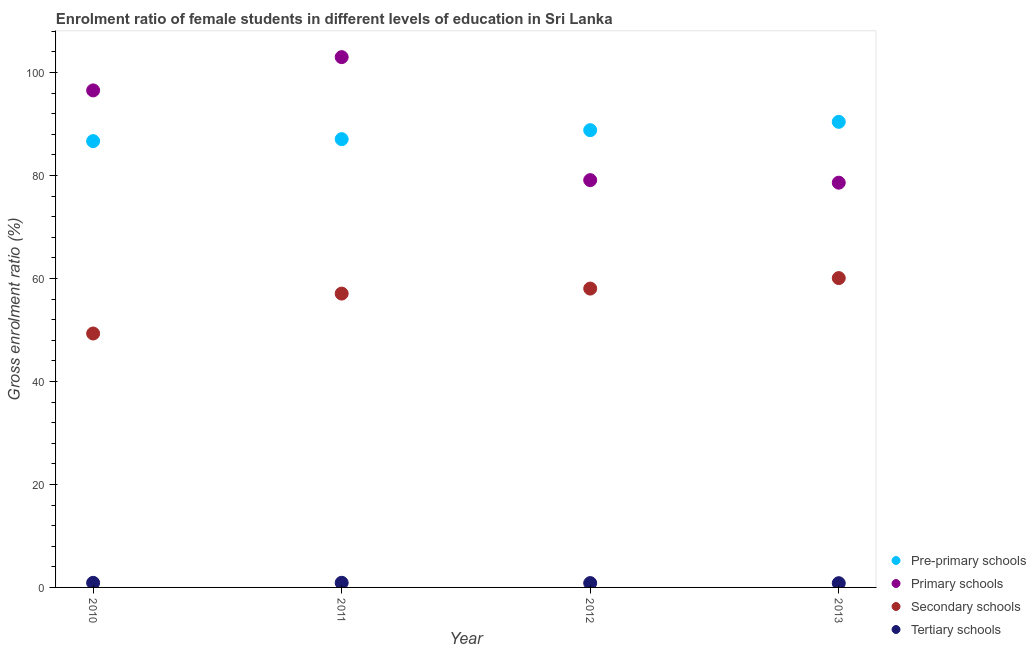How many different coloured dotlines are there?
Offer a terse response. 4. Is the number of dotlines equal to the number of legend labels?
Keep it short and to the point. Yes. What is the gross enrolment ratio(male) in secondary schools in 2013?
Provide a succinct answer. 60.08. Across all years, what is the maximum gross enrolment ratio(male) in pre-primary schools?
Offer a very short reply. 90.43. Across all years, what is the minimum gross enrolment ratio(male) in pre-primary schools?
Provide a short and direct response. 86.68. In which year was the gross enrolment ratio(male) in tertiary schools maximum?
Offer a very short reply. 2011. In which year was the gross enrolment ratio(male) in secondary schools minimum?
Your answer should be compact. 2010. What is the total gross enrolment ratio(male) in pre-primary schools in the graph?
Your answer should be very brief. 352.99. What is the difference between the gross enrolment ratio(male) in secondary schools in 2012 and that in 2013?
Offer a very short reply. -2.04. What is the difference between the gross enrolment ratio(male) in secondary schools in 2012 and the gross enrolment ratio(male) in tertiary schools in 2013?
Provide a short and direct response. 57.22. What is the average gross enrolment ratio(male) in primary schools per year?
Give a very brief answer. 89.31. In the year 2012, what is the difference between the gross enrolment ratio(male) in primary schools and gross enrolment ratio(male) in tertiary schools?
Offer a terse response. 78.27. What is the ratio of the gross enrolment ratio(male) in tertiary schools in 2010 to that in 2012?
Keep it short and to the point. 1.06. What is the difference between the highest and the second highest gross enrolment ratio(male) in pre-primary schools?
Offer a terse response. 1.62. What is the difference between the highest and the lowest gross enrolment ratio(male) in secondary schools?
Give a very brief answer. 10.76. In how many years, is the gross enrolment ratio(male) in pre-primary schools greater than the average gross enrolment ratio(male) in pre-primary schools taken over all years?
Offer a very short reply. 2. Is it the case that in every year, the sum of the gross enrolment ratio(male) in secondary schools and gross enrolment ratio(male) in primary schools is greater than the sum of gross enrolment ratio(male) in tertiary schools and gross enrolment ratio(male) in pre-primary schools?
Give a very brief answer. Yes. Is it the case that in every year, the sum of the gross enrolment ratio(male) in pre-primary schools and gross enrolment ratio(male) in primary schools is greater than the gross enrolment ratio(male) in secondary schools?
Keep it short and to the point. Yes. Does the gross enrolment ratio(male) in primary schools monotonically increase over the years?
Your answer should be compact. No. Is the gross enrolment ratio(male) in primary schools strictly greater than the gross enrolment ratio(male) in secondary schools over the years?
Your response must be concise. Yes. Is the gross enrolment ratio(male) in pre-primary schools strictly less than the gross enrolment ratio(male) in tertiary schools over the years?
Ensure brevity in your answer.  No. Where does the legend appear in the graph?
Provide a short and direct response. Bottom right. What is the title of the graph?
Your answer should be compact. Enrolment ratio of female students in different levels of education in Sri Lanka. Does "Oil" appear as one of the legend labels in the graph?
Make the answer very short. No. What is the label or title of the X-axis?
Your answer should be compact. Year. What is the Gross enrolment ratio (%) in Pre-primary schools in 2010?
Offer a terse response. 86.68. What is the Gross enrolment ratio (%) in Primary schools in 2010?
Give a very brief answer. 96.53. What is the Gross enrolment ratio (%) in Secondary schools in 2010?
Keep it short and to the point. 49.32. What is the Gross enrolment ratio (%) of Tertiary schools in 2010?
Give a very brief answer. 0.89. What is the Gross enrolment ratio (%) of Pre-primary schools in 2011?
Keep it short and to the point. 87.07. What is the Gross enrolment ratio (%) of Primary schools in 2011?
Your response must be concise. 103. What is the Gross enrolment ratio (%) of Secondary schools in 2011?
Provide a succinct answer. 57.07. What is the Gross enrolment ratio (%) of Tertiary schools in 2011?
Provide a succinct answer. 0.9. What is the Gross enrolment ratio (%) in Pre-primary schools in 2012?
Your answer should be compact. 88.81. What is the Gross enrolment ratio (%) of Primary schools in 2012?
Keep it short and to the point. 79.11. What is the Gross enrolment ratio (%) in Secondary schools in 2012?
Make the answer very short. 58.04. What is the Gross enrolment ratio (%) of Tertiary schools in 2012?
Offer a very short reply. 0.84. What is the Gross enrolment ratio (%) of Pre-primary schools in 2013?
Offer a very short reply. 90.43. What is the Gross enrolment ratio (%) in Primary schools in 2013?
Your answer should be very brief. 78.61. What is the Gross enrolment ratio (%) of Secondary schools in 2013?
Give a very brief answer. 60.08. What is the Gross enrolment ratio (%) in Tertiary schools in 2013?
Offer a terse response. 0.82. Across all years, what is the maximum Gross enrolment ratio (%) of Pre-primary schools?
Your response must be concise. 90.43. Across all years, what is the maximum Gross enrolment ratio (%) of Primary schools?
Make the answer very short. 103. Across all years, what is the maximum Gross enrolment ratio (%) in Secondary schools?
Offer a terse response. 60.08. Across all years, what is the maximum Gross enrolment ratio (%) of Tertiary schools?
Provide a short and direct response. 0.9. Across all years, what is the minimum Gross enrolment ratio (%) in Pre-primary schools?
Provide a short and direct response. 86.68. Across all years, what is the minimum Gross enrolment ratio (%) in Primary schools?
Provide a succinct answer. 78.61. Across all years, what is the minimum Gross enrolment ratio (%) of Secondary schools?
Your response must be concise. 49.32. Across all years, what is the minimum Gross enrolment ratio (%) in Tertiary schools?
Ensure brevity in your answer.  0.82. What is the total Gross enrolment ratio (%) in Pre-primary schools in the graph?
Offer a very short reply. 352.99. What is the total Gross enrolment ratio (%) of Primary schools in the graph?
Keep it short and to the point. 357.25. What is the total Gross enrolment ratio (%) in Secondary schools in the graph?
Your response must be concise. 224.52. What is the total Gross enrolment ratio (%) of Tertiary schools in the graph?
Provide a short and direct response. 3.46. What is the difference between the Gross enrolment ratio (%) of Pre-primary schools in 2010 and that in 2011?
Your response must be concise. -0.38. What is the difference between the Gross enrolment ratio (%) of Primary schools in 2010 and that in 2011?
Your response must be concise. -6.46. What is the difference between the Gross enrolment ratio (%) in Secondary schools in 2010 and that in 2011?
Make the answer very short. -7.75. What is the difference between the Gross enrolment ratio (%) of Tertiary schools in 2010 and that in 2011?
Offer a terse response. -0.01. What is the difference between the Gross enrolment ratio (%) of Pre-primary schools in 2010 and that in 2012?
Provide a succinct answer. -2.13. What is the difference between the Gross enrolment ratio (%) in Primary schools in 2010 and that in 2012?
Provide a short and direct response. 17.43. What is the difference between the Gross enrolment ratio (%) of Secondary schools in 2010 and that in 2012?
Ensure brevity in your answer.  -8.73. What is the difference between the Gross enrolment ratio (%) in Tertiary schools in 2010 and that in 2012?
Your answer should be very brief. 0.05. What is the difference between the Gross enrolment ratio (%) of Pre-primary schools in 2010 and that in 2013?
Ensure brevity in your answer.  -3.75. What is the difference between the Gross enrolment ratio (%) in Primary schools in 2010 and that in 2013?
Ensure brevity in your answer.  17.92. What is the difference between the Gross enrolment ratio (%) of Secondary schools in 2010 and that in 2013?
Ensure brevity in your answer.  -10.76. What is the difference between the Gross enrolment ratio (%) in Tertiary schools in 2010 and that in 2013?
Keep it short and to the point. 0.07. What is the difference between the Gross enrolment ratio (%) of Pre-primary schools in 2011 and that in 2012?
Offer a very short reply. -1.74. What is the difference between the Gross enrolment ratio (%) of Primary schools in 2011 and that in 2012?
Your answer should be compact. 23.89. What is the difference between the Gross enrolment ratio (%) of Secondary schools in 2011 and that in 2012?
Offer a very short reply. -0.97. What is the difference between the Gross enrolment ratio (%) of Tertiary schools in 2011 and that in 2012?
Keep it short and to the point. 0.06. What is the difference between the Gross enrolment ratio (%) of Pre-primary schools in 2011 and that in 2013?
Your answer should be compact. -3.36. What is the difference between the Gross enrolment ratio (%) in Primary schools in 2011 and that in 2013?
Make the answer very short. 24.38. What is the difference between the Gross enrolment ratio (%) of Secondary schools in 2011 and that in 2013?
Ensure brevity in your answer.  -3.01. What is the difference between the Gross enrolment ratio (%) of Tertiary schools in 2011 and that in 2013?
Provide a short and direct response. 0.08. What is the difference between the Gross enrolment ratio (%) in Pre-primary schools in 2012 and that in 2013?
Your response must be concise. -1.62. What is the difference between the Gross enrolment ratio (%) of Primary schools in 2012 and that in 2013?
Provide a short and direct response. 0.49. What is the difference between the Gross enrolment ratio (%) in Secondary schools in 2012 and that in 2013?
Make the answer very short. -2.04. What is the difference between the Gross enrolment ratio (%) of Tertiary schools in 2012 and that in 2013?
Give a very brief answer. 0.02. What is the difference between the Gross enrolment ratio (%) in Pre-primary schools in 2010 and the Gross enrolment ratio (%) in Primary schools in 2011?
Offer a terse response. -16.31. What is the difference between the Gross enrolment ratio (%) in Pre-primary schools in 2010 and the Gross enrolment ratio (%) in Secondary schools in 2011?
Offer a very short reply. 29.61. What is the difference between the Gross enrolment ratio (%) in Pre-primary schools in 2010 and the Gross enrolment ratio (%) in Tertiary schools in 2011?
Give a very brief answer. 85.78. What is the difference between the Gross enrolment ratio (%) of Primary schools in 2010 and the Gross enrolment ratio (%) of Secondary schools in 2011?
Ensure brevity in your answer.  39.46. What is the difference between the Gross enrolment ratio (%) of Primary schools in 2010 and the Gross enrolment ratio (%) of Tertiary schools in 2011?
Your answer should be compact. 95.63. What is the difference between the Gross enrolment ratio (%) in Secondary schools in 2010 and the Gross enrolment ratio (%) in Tertiary schools in 2011?
Give a very brief answer. 48.42. What is the difference between the Gross enrolment ratio (%) of Pre-primary schools in 2010 and the Gross enrolment ratio (%) of Primary schools in 2012?
Ensure brevity in your answer.  7.58. What is the difference between the Gross enrolment ratio (%) in Pre-primary schools in 2010 and the Gross enrolment ratio (%) in Secondary schools in 2012?
Keep it short and to the point. 28.64. What is the difference between the Gross enrolment ratio (%) of Pre-primary schools in 2010 and the Gross enrolment ratio (%) of Tertiary schools in 2012?
Your response must be concise. 85.84. What is the difference between the Gross enrolment ratio (%) in Primary schools in 2010 and the Gross enrolment ratio (%) in Secondary schools in 2012?
Keep it short and to the point. 38.49. What is the difference between the Gross enrolment ratio (%) of Primary schools in 2010 and the Gross enrolment ratio (%) of Tertiary schools in 2012?
Give a very brief answer. 95.69. What is the difference between the Gross enrolment ratio (%) of Secondary schools in 2010 and the Gross enrolment ratio (%) of Tertiary schools in 2012?
Ensure brevity in your answer.  48.48. What is the difference between the Gross enrolment ratio (%) of Pre-primary schools in 2010 and the Gross enrolment ratio (%) of Primary schools in 2013?
Keep it short and to the point. 8.07. What is the difference between the Gross enrolment ratio (%) of Pre-primary schools in 2010 and the Gross enrolment ratio (%) of Secondary schools in 2013?
Your answer should be compact. 26.6. What is the difference between the Gross enrolment ratio (%) of Pre-primary schools in 2010 and the Gross enrolment ratio (%) of Tertiary schools in 2013?
Offer a very short reply. 85.86. What is the difference between the Gross enrolment ratio (%) of Primary schools in 2010 and the Gross enrolment ratio (%) of Secondary schools in 2013?
Your response must be concise. 36.45. What is the difference between the Gross enrolment ratio (%) of Primary schools in 2010 and the Gross enrolment ratio (%) of Tertiary schools in 2013?
Make the answer very short. 95.71. What is the difference between the Gross enrolment ratio (%) in Secondary schools in 2010 and the Gross enrolment ratio (%) in Tertiary schools in 2013?
Offer a terse response. 48.49. What is the difference between the Gross enrolment ratio (%) in Pre-primary schools in 2011 and the Gross enrolment ratio (%) in Primary schools in 2012?
Keep it short and to the point. 7.96. What is the difference between the Gross enrolment ratio (%) of Pre-primary schools in 2011 and the Gross enrolment ratio (%) of Secondary schools in 2012?
Provide a short and direct response. 29.02. What is the difference between the Gross enrolment ratio (%) in Pre-primary schools in 2011 and the Gross enrolment ratio (%) in Tertiary schools in 2012?
Your answer should be compact. 86.23. What is the difference between the Gross enrolment ratio (%) of Primary schools in 2011 and the Gross enrolment ratio (%) of Secondary schools in 2012?
Make the answer very short. 44.95. What is the difference between the Gross enrolment ratio (%) of Primary schools in 2011 and the Gross enrolment ratio (%) of Tertiary schools in 2012?
Ensure brevity in your answer.  102.16. What is the difference between the Gross enrolment ratio (%) in Secondary schools in 2011 and the Gross enrolment ratio (%) in Tertiary schools in 2012?
Offer a terse response. 56.23. What is the difference between the Gross enrolment ratio (%) of Pre-primary schools in 2011 and the Gross enrolment ratio (%) of Primary schools in 2013?
Provide a succinct answer. 8.45. What is the difference between the Gross enrolment ratio (%) in Pre-primary schools in 2011 and the Gross enrolment ratio (%) in Secondary schools in 2013?
Make the answer very short. 26.99. What is the difference between the Gross enrolment ratio (%) of Pre-primary schools in 2011 and the Gross enrolment ratio (%) of Tertiary schools in 2013?
Offer a very short reply. 86.25. What is the difference between the Gross enrolment ratio (%) of Primary schools in 2011 and the Gross enrolment ratio (%) of Secondary schools in 2013?
Your response must be concise. 42.92. What is the difference between the Gross enrolment ratio (%) in Primary schools in 2011 and the Gross enrolment ratio (%) in Tertiary schools in 2013?
Your response must be concise. 102.18. What is the difference between the Gross enrolment ratio (%) in Secondary schools in 2011 and the Gross enrolment ratio (%) in Tertiary schools in 2013?
Your response must be concise. 56.25. What is the difference between the Gross enrolment ratio (%) of Pre-primary schools in 2012 and the Gross enrolment ratio (%) of Primary schools in 2013?
Your response must be concise. 10.2. What is the difference between the Gross enrolment ratio (%) of Pre-primary schools in 2012 and the Gross enrolment ratio (%) of Secondary schools in 2013?
Ensure brevity in your answer.  28.73. What is the difference between the Gross enrolment ratio (%) of Pre-primary schools in 2012 and the Gross enrolment ratio (%) of Tertiary schools in 2013?
Make the answer very short. 87.99. What is the difference between the Gross enrolment ratio (%) in Primary schools in 2012 and the Gross enrolment ratio (%) in Secondary schools in 2013?
Your answer should be very brief. 19.03. What is the difference between the Gross enrolment ratio (%) of Primary schools in 2012 and the Gross enrolment ratio (%) of Tertiary schools in 2013?
Offer a terse response. 78.29. What is the difference between the Gross enrolment ratio (%) of Secondary schools in 2012 and the Gross enrolment ratio (%) of Tertiary schools in 2013?
Offer a terse response. 57.22. What is the average Gross enrolment ratio (%) of Pre-primary schools per year?
Your answer should be very brief. 88.25. What is the average Gross enrolment ratio (%) of Primary schools per year?
Provide a short and direct response. 89.31. What is the average Gross enrolment ratio (%) in Secondary schools per year?
Your response must be concise. 56.13. What is the average Gross enrolment ratio (%) of Tertiary schools per year?
Make the answer very short. 0.86. In the year 2010, what is the difference between the Gross enrolment ratio (%) in Pre-primary schools and Gross enrolment ratio (%) in Primary schools?
Give a very brief answer. -9.85. In the year 2010, what is the difference between the Gross enrolment ratio (%) of Pre-primary schools and Gross enrolment ratio (%) of Secondary schools?
Provide a succinct answer. 37.37. In the year 2010, what is the difference between the Gross enrolment ratio (%) of Pre-primary schools and Gross enrolment ratio (%) of Tertiary schools?
Your answer should be compact. 85.79. In the year 2010, what is the difference between the Gross enrolment ratio (%) in Primary schools and Gross enrolment ratio (%) in Secondary schools?
Ensure brevity in your answer.  47.22. In the year 2010, what is the difference between the Gross enrolment ratio (%) in Primary schools and Gross enrolment ratio (%) in Tertiary schools?
Your response must be concise. 95.64. In the year 2010, what is the difference between the Gross enrolment ratio (%) in Secondary schools and Gross enrolment ratio (%) in Tertiary schools?
Give a very brief answer. 48.43. In the year 2011, what is the difference between the Gross enrolment ratio (%) in Pre-primary schools and Gross enrolment ratio (%) in Primary schools?
Give a very brief answer. -15.93. In the year 2011, what is the difference between the Gross enrolment ratio (%) of Pre-primary schools and Gross enrolment ratio (%) of Secondary schools?
Offer a terse response. 30. In the year 2011, what is the difference between the Gross enrolment ratio (%) of Pre-primary schools and Gross enrolment ratio (%) of Tertiary schools?
Offer a terse response. 86.17. In the year 2011, what is the difference between the Gross enrolment ratio (%) in Primary schools and Gross enrolment ratio (%) in Secondary schools?
Your answer should be compact. 45.93. In the year 2011, what is the difference between the Gross enrolment ratio (%) of Primary schools and Gross enrolment ratio (%) of Tertiary schools?
Keep it short and to the point. 102.1. In the year 2011, what is the difference between the Gross enrolment ratio (%) of Secondary schools and Gross enrolment ratio (%) of Tertiary schools?
Your answer should be very brief. 56.17. In the year 2012, what is the difference between the Gross enrolment ratio (%) in Pre-primary schools and Gross enrolment ratio (%) in Primary schools?
Keep it short and to the point. 9.7. In the year 2012, what is the difference between the Gross enrolment ratio (%) in Pre-primary schools and Gross enrolment ratio (%) in Secondary schools?
Your answer should be compact. 30.77. In the year 2012, what is the difference between the Gross enrolment ratio (%) in Pre-primary schools and Gross enrolment ratio (%) in Tertiary schools?
Offer a very short reply. 87.97. In the year 2012, what is the difference between the Gross enrolment ratio (%) of Primary schools and Gross enrolment ratio (%) of Secondary schools?
Your answer should be compact. 21.06. In the year 2012, what is the difference between the Gross enrolment ratio (%) of Primary schools and Gross enrolment ratio (%) of Tertiary schools?
Give a very brief answer. 78.27. In the year 2012, what is the difference between the Gross enrolment ratio (%) in Secondary schools and Gross enrolment ratio (%) in Tertiary schools?
Provide a succinct answer. 57.2. In the year 2013, what is the difference between the Gross enrolment ratio (%) in Pre-primary schools and Gross enrolment ratio (%) in Primary schools?
Your answer should be very brief. 11.82. In the year 2013, what is the difference between the Gross enrolment ratio (%) in Pre-primary schools and Gross enrolment ratio (%) in Secondary schools?
Ensure brevity in your answer.  30.35. In the year 2013, what is the difference between the Gross enrolment ratio (%) of Pre-primary schools and Gross enrolment ratio (%) of Tertiary schools?
Keep it short and to the point. 89.61. In the year 2013, what is the difference between the Gross enrolment ratio (%) in Primary schools and Gross enrolment ratio (%) in Secondary schools?
Provide a short and direct response. 18.53. In the year 2013, what is the difference between the Gross enrolment ratio (%) of Primary schools and Gross enrolment ratio (%) of Tertiary schools?
Provide a short and direct response. 77.79. In the year 2013, what is the difference between the Gross enrolment ratio (%) of Secondary schools and Gross enrolment ratio (%) of Tertiary schools?
Provide a succinct answer. 59.26. What is the ratio of the Gross enrolment ratio (%) in Pre-primary schools in 2010 to that in 2011?
Provide a succinct answer. 1. What is the ratio of the Gross enrolment ratio (%) in Primary schools in 2010 to that in 2011?
Your answer should be very brief. 0.94. What is the ratio of the Gross enrolment ratio (%) in Secondary schools in 2010 to that in 2011?
Your answer should be compact. 0.86. What is the ratio of the Gross enrolment ratio (%) in Tertiary schools in 2010 to that in 2011?
Offer a very short reply. 0.99. What is the ratio of the Gross enrolment ratio (%) of Pre-primary schools in 2010 to that in 2012?
Give a very brief answer. 0.98. What is the ratio of the Gross enrolment ratio (%) in Primary schools in 2010 to that in 2012?
Your response must be concise. 1.22. What is the ratio of the Gross enrolment ratio (%) in Secondary schools in 2010 to that in 2012?
Make the answer very short. 0.85. What is the ratio of the Gross enrolment ratio (%) of Tertiary schools in 2010 to that in 2012?
Provide a succinct answer. 1.06. What is the ratio of the Gross enrolment ratio (%) of Pre-primary schools in 2010 to that in 2013?
Your answer should be very brief. 0.96. What is the ratio of the Gross enrolment ratio (%) of Primary schools in 2010 to that in 2013?
Your answer should be very brief. 1.23. What is the ratio of the Gross enrolment ratio (%) in Secondary schools in 2010 to that in 2013?
Ensure brevity in your answer.  0.82. What is the ratio of the Gross enrolment ratio (%) of Tertiary schools in 2010 to that in 2013?
Provide a short and direct response. 1.08. What is the ratio of the Gross enrolment ratio (%) in Pre-primary schools in 2011 to that in 2012?
Ensure brevity in your answer.  0.98. What is the ratio of the Gross enrolment ratio (%) of Primary schools in 2011 to that in 2012?
Provide a succinct answer. 1.3. What is the ratio of the Gross enrolment ratio (%) in Secondary schools in 2011 to that in 2012?
Your answer should be very brief. 0.98. What is the ratio of the Gross enrolment ratio (%) of Tertiary schools in 2011 to that in 2012?
Offer a very short reply. 1.07. What is the ratio of the Gross enrolment ratio (%) of Pre-primary schools in 2011 to that in 2013?
Offer a very short reply. 0.96. What is the ratio of the Gross enrolment ratio (%) in Primary schools in 2011 to that in 2013?
Provide a succinct answer. 1.31. What is the ratio of the Gross enrolment ratio (%) in Secondary schools in 2011 to that in 2013?
Provide a succinct answer. 0.95. What is the ratio of the Gross enrolment ratio (%) of Tertiary schools in 2011 to that in 2013?
Your answer should be compact. 1.1. What is the ratio of the Gross enrolment ratio (%) of Pre-primary schools in 2012 to that in 2013?
Make the answer very short. 0.98. What is the ratio of the Gross enrolment ratio (%) of Secondary schools in 2012 to that in 2013?
Provide a succinct answer. 0.97. What is the ratio of the Gross enrolment ratio (%) of Tertiary schools in 2012 to that in 2013?
Provide a succinct answer. 1.02. What is the difference between the highest and the second highest Gross enrolment ratio (%) of Pre-primary schools?
Keep it short and to the point. 1.62. What is the difference between the highest and the second highest Gross enrolment ratio (%) in Primary schools?
Offer a terse response. 6.46. What is the difference between the highest and the second highest Gross enrolment ratio (%) of Secondary schools?
Your answer should be compact. 2.04. What is the difference between the highest and the second highest Gross enrolment ratio (%) in Tertiary schools?
Provide a short and direct response. 0.01. What is the difference between the highest and the lowest Gross enrolment ratio (%) of Pre-primary schools?
Your answer should be very brief. 3.75. What is the difference between the highest and the lowest Gross enrolment ratio (%) of Primary schools?
Provide a short and direct response. 24.38. What is the difference between the highest and the lowest Gross enrolment ratio (%) of Secondary schools?
Provide a short and direct response. 10.76. What is the difference between the highest and the lowest Gross enrolment ratio (%) in Tertiary schools?
Ensure brevity in your answer.  0.08. 